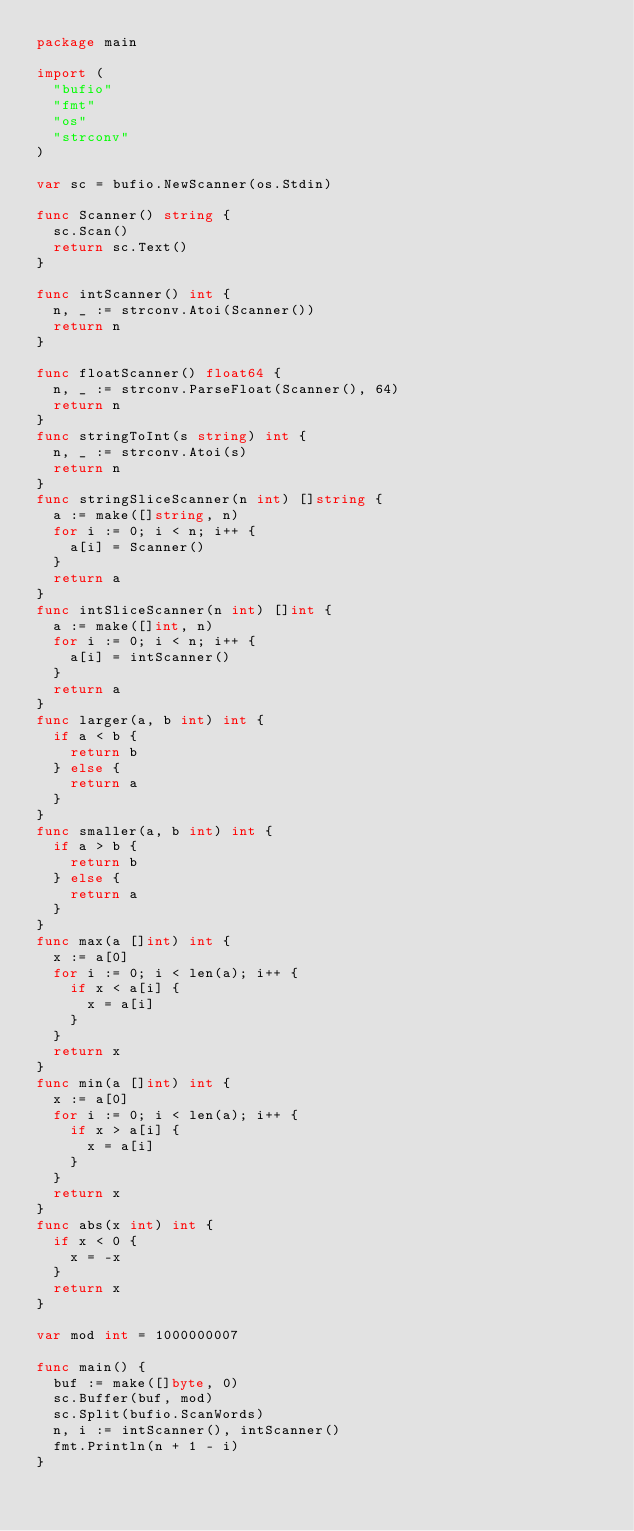<code> <loc_0><loc_0><loc_500><loc_500><_Go_>package main

import (
	"bufio"
	"fmt"
	"os"
	"strconv"
)

var sc = bufio.NewScanner(os.Stdin)

func Scanner() string {
	sc.Scan()
	return sc.Text()
}

func intScanner() int {
	n, _ := strconv.Atoi(Scanner())
	return n
}

func floatScanner() float64 {
	n, _ := strconv.ParseFloat(Scanner(), 64)
	return n
}
func stringToInt(s string) int {
	n, _ := strconv.Atoi(s)
	return n
}
func stringSliceScanner(n int) []string {
	a := make([]string, n)
	for i := 0; i < n; i++ {
		a[i] = Scanner()
	}
	return a
}
func intSliceScanner(n int) []int {
	a := make([]int, n)
	for i := 0; i < n; i++ {
		a[i] = intScanner()
	}
	return a
}
func larger(a, b int) int {
	if a < b {
		return b
	} else {
		return a
	}
}
func smaller(a, b int) int {
	if a > b {
		return b
	} else {
		return a
	}
}
func max(a []int) int {
	x := a[0]
	for i := 0; i < len(a); i++ {
		if x < a[i] {
			x = a[i]
		}
	}
	return x
}
func min(a []int) int {
	x := a[0]
	for i := 0; i < len(a); i++ {
		if x > a[i] {
			x = a[i]
		}
	}
	return x
}
func abs(x int) int {
	if x < 0 {
		x = -x
	}
	return x
}

var mod int = 1000000007

func main() {
	buf := make([]byte, 0)
	sc.Buffer(buf, mod)
	sc.Split(bufio.ScanWords)
	n, i := intScanner(), intScanner()
	fmt.Println(n + 1 - i)
}
</code> 